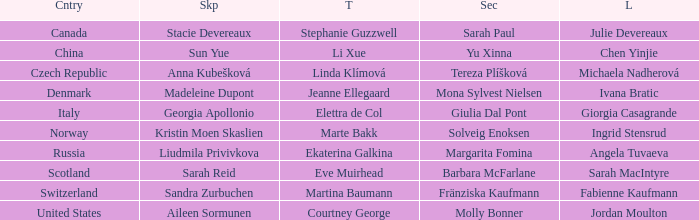What skip has norway as the country? Kristin Moen Skaslien. 